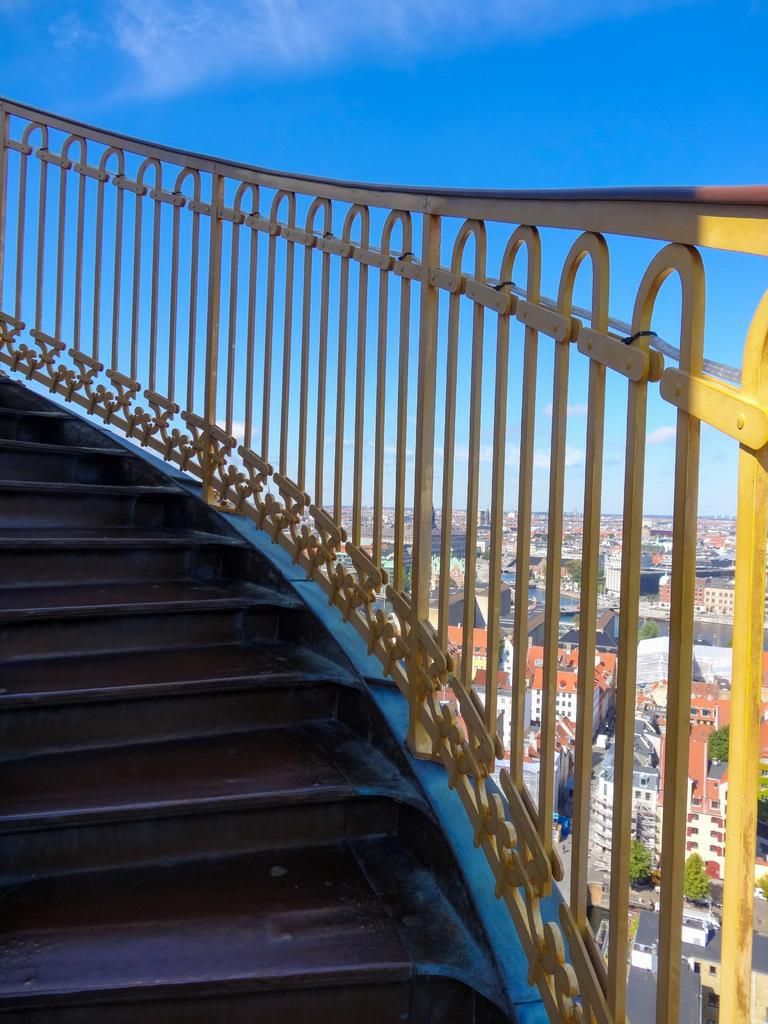What is located in the center of the image? There are stairs and fencing in the center of the image. What can be seen in the background of the image? There are buildings, trees, roads, and the sky visible in the background of the image. Are there any clouds in the sky? Yes, there are clouds in the sky in the background of the image. What type of lace can be seen on the trees in the image? There is no lace present on the trees in the image; the trees are natural and do not have any lace. What type of food is being served on the stairs in the image? There is no food present on the stairs in the image; the stairs are a structural element and not related to food. 